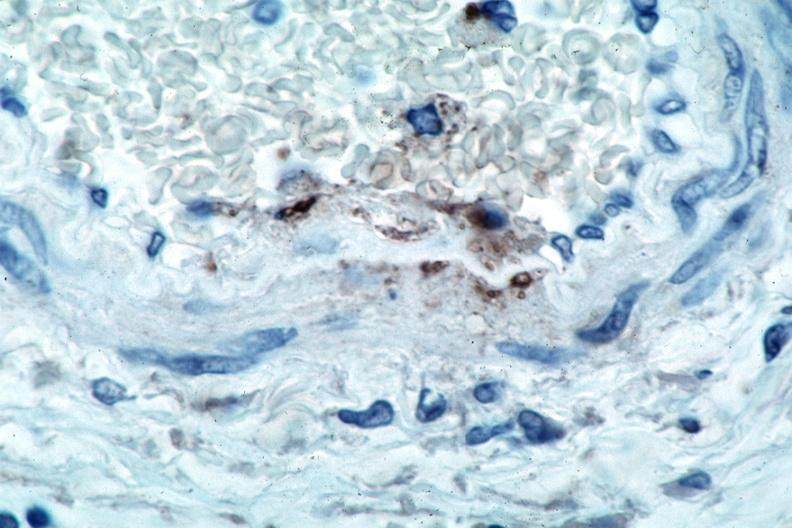what does this image show?
Answer the question using a single word or phrase. Vasculitis 